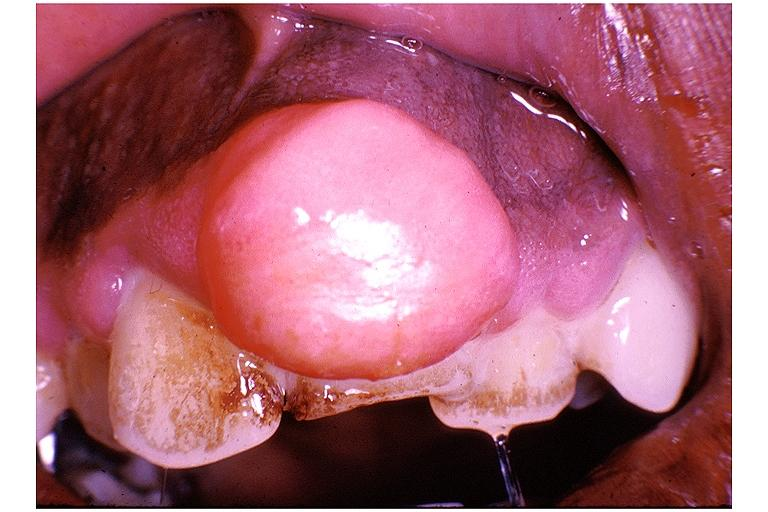what is present?
Answer the question using a single word or phrase. Oral 